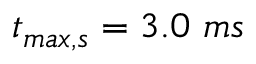Convert formula to latex. <formula><loc_0><loc_0><loc_500><loc_500>t _ { \max , s } = 3 . 0 m s</formula> 